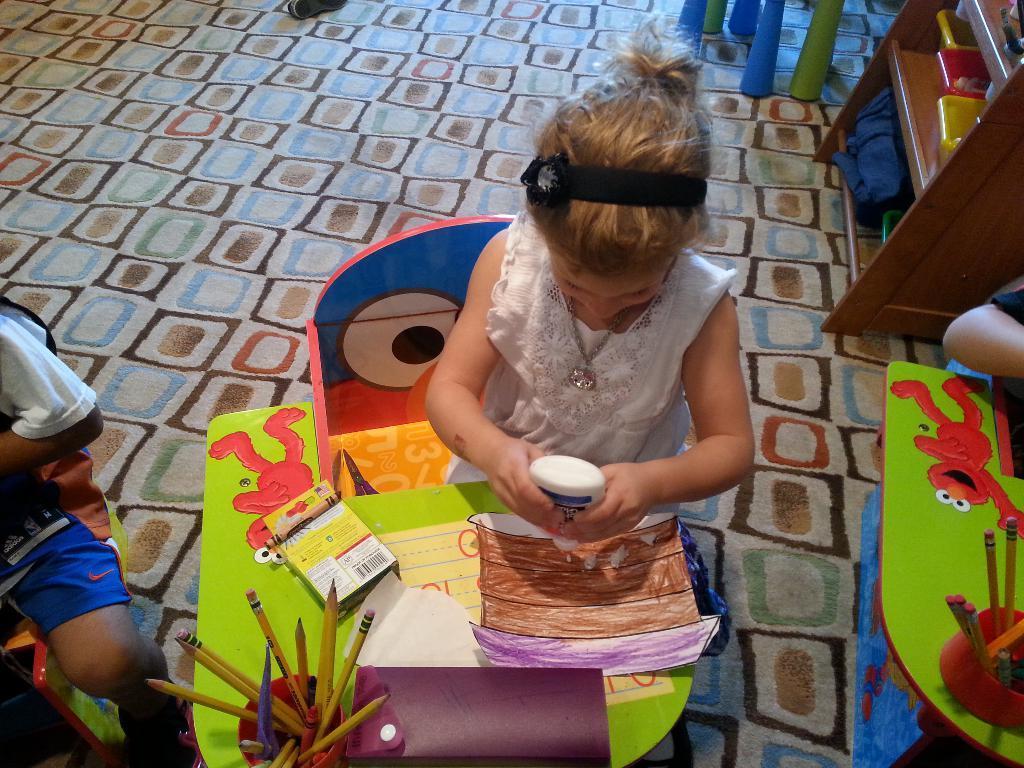Please provide a concise description of this image. In the middle a little cute girl is sitting on the chair and doing drawing, she wore a white color dress. There are pencils in the bottom of this image in a cup. 